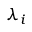<formula> <loc_0><loc_0><loc_500><loc_500>\lambda _ { i }</formula> 